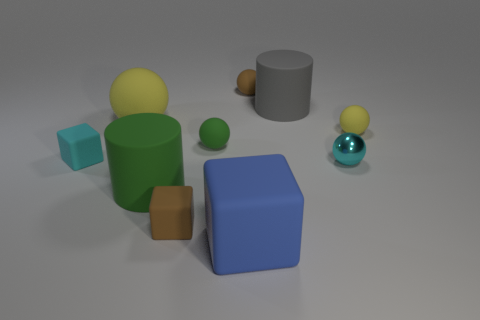How many blue objects are either tiny matte blocks or big cylinders?
Your response must be concise. 0. Are there any large matte objects behind the blue rubber object?
Keep it short and to the point. Yes. What size is the blue cube?
Your answer should be very brief. Large. There is another rubber object that is the same shape as the big green rubber object; what is its size?
Offer a very short reply. Large. There is a tiny block that is on the right side of the cyan matte thing; what number of cylinders are left of it?
Make the answer very short. 1. Does the big cylinder that is in front of the big gray matte thing have the same material as the tiny object to the left of the green cylinder?
Make the answer very short. Yes. What number of other tiny rubber objects are the same shape as the small green object?
Provide a short and direct response. 2. How many rubber blocks have the same color as the tiny metallic ball?
Ensure brevity in your answer.  1. There is a yellow matte thing right of the big green rubber cylinder; is its shape the same as the green object that is behind the tiny metal object?
Your answer should be compact. Yes. There is a small brown object in front of the cyan object left of the brown matte sphere; how many tiny matte objects are right of it?
Your answer should be very brief. 3. 